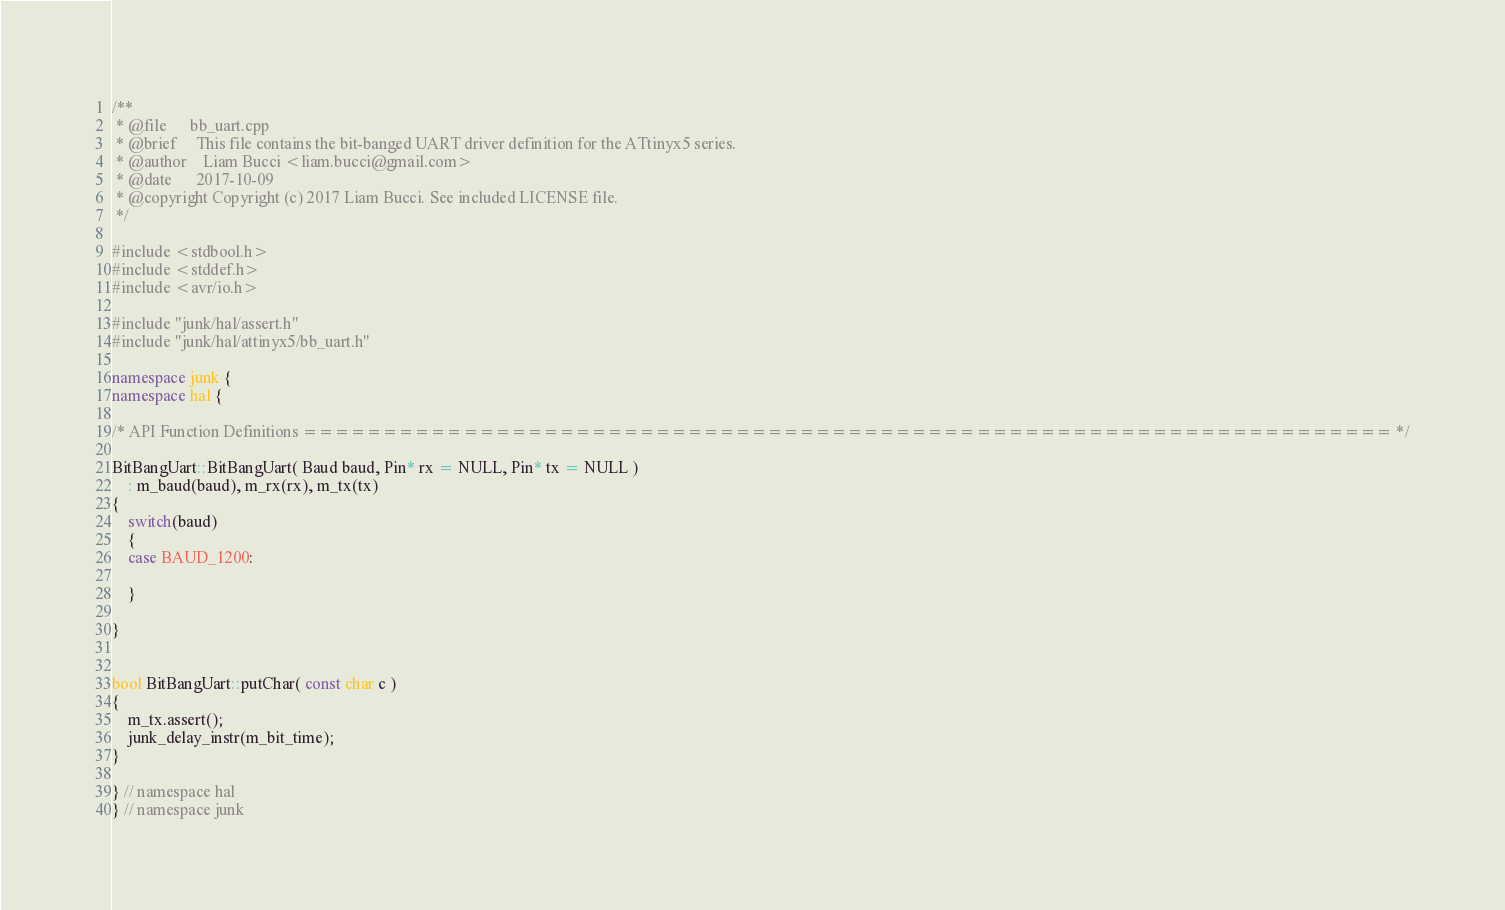<code> <loc_0><loc_0><loc_500><loc_500><_C++_>/**
 * @file      bb_uart.cpp
 * @brief     This file contains the bit-banged UART driver definition for the ATtinyx5 series.
 * @author    Liam Bucci <liam.bucci@gmail.com>
 * @date      2017-10-09
 * @copyright Copyright (c) 2017 Liam Bucci. See included LICENSE file.
 */

#include <stdbool.h>
#include <stddef.h>
#include <avr/io.h>

#include "junk/hal/assert.h"
#include "junk/hal/attinyx5/bb_uart.h"

namespace junk {
namespace hal {

/* API Function Definitions ==================================================================== */

BitBangUart::BitBangUart( Baud baud, Pin* rx = NULL, Pin* tx = NULL )
    : m_baud(baud), m_rx(rx), m_tx(tx)
{
    switch(baud)
    {
    case BAUD_1200:

    }

}


bool BitBangUart::putChar( const char c )
{
    m_tx.assert();
    junk_delay_instr(m_bit_time);
}

} // namespace hal
} // namespace junk
</code> 